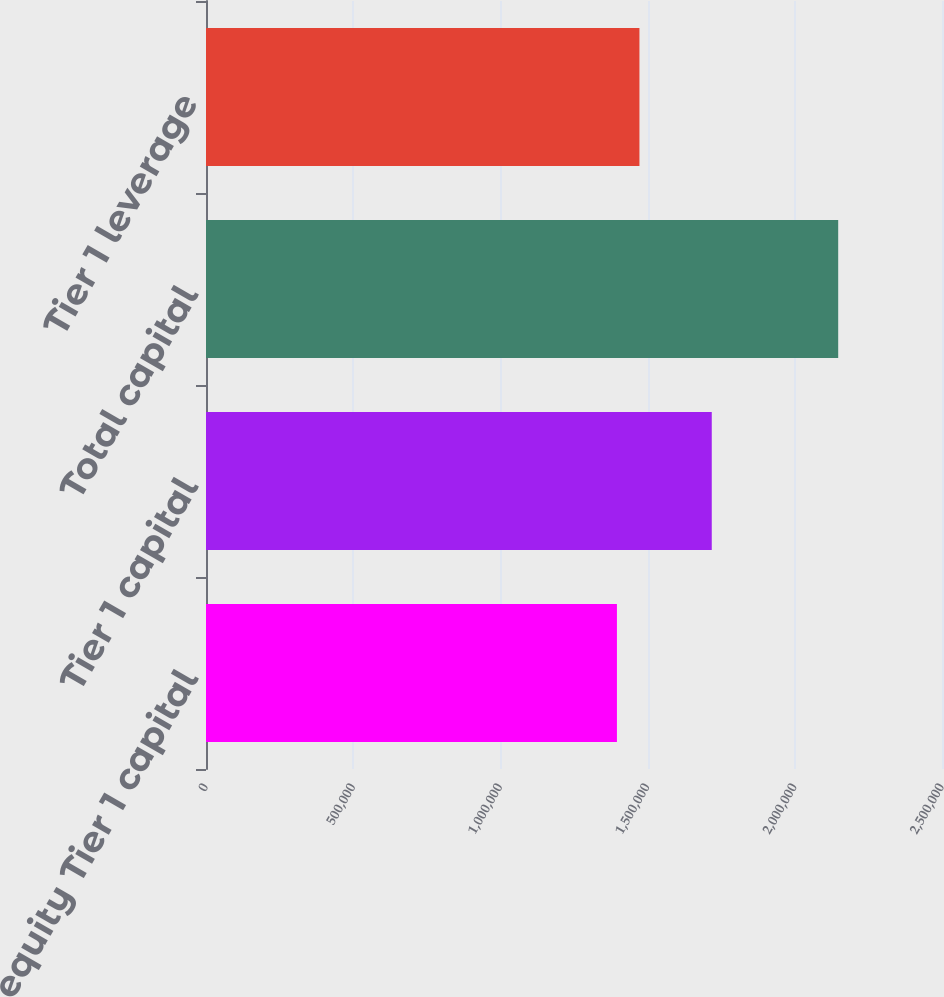Convert chart. <chart><loc_0><loc_0><loc_500><loc_500><bar_chart><fcel>Common equity Tier 1 capital<fcel>Tier 1 capital<fcel>Total capital<fcel>Tier 1 leverage<nl><fcel>1.39582e+06<fcel>1.71794e+06<fcel>2.14742e+06<fcel>1.4723e+06<nl></chart> 